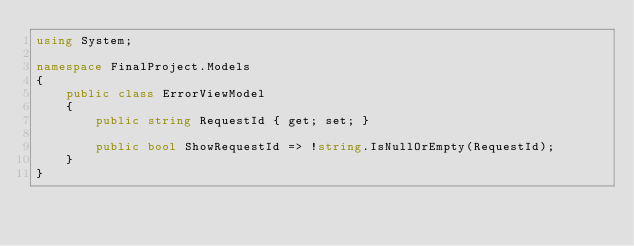<code> <loc_0><loc_0><loc_500><loc_500><_C#_>using System;

namespace FinalProject.Models
{
    public class ErrorViewModel
    {
        public string RequestId { get; set; }

        public bool ShowRequestId => !string.IsNullOrEmpty(RequestId);
    }
}</code> 